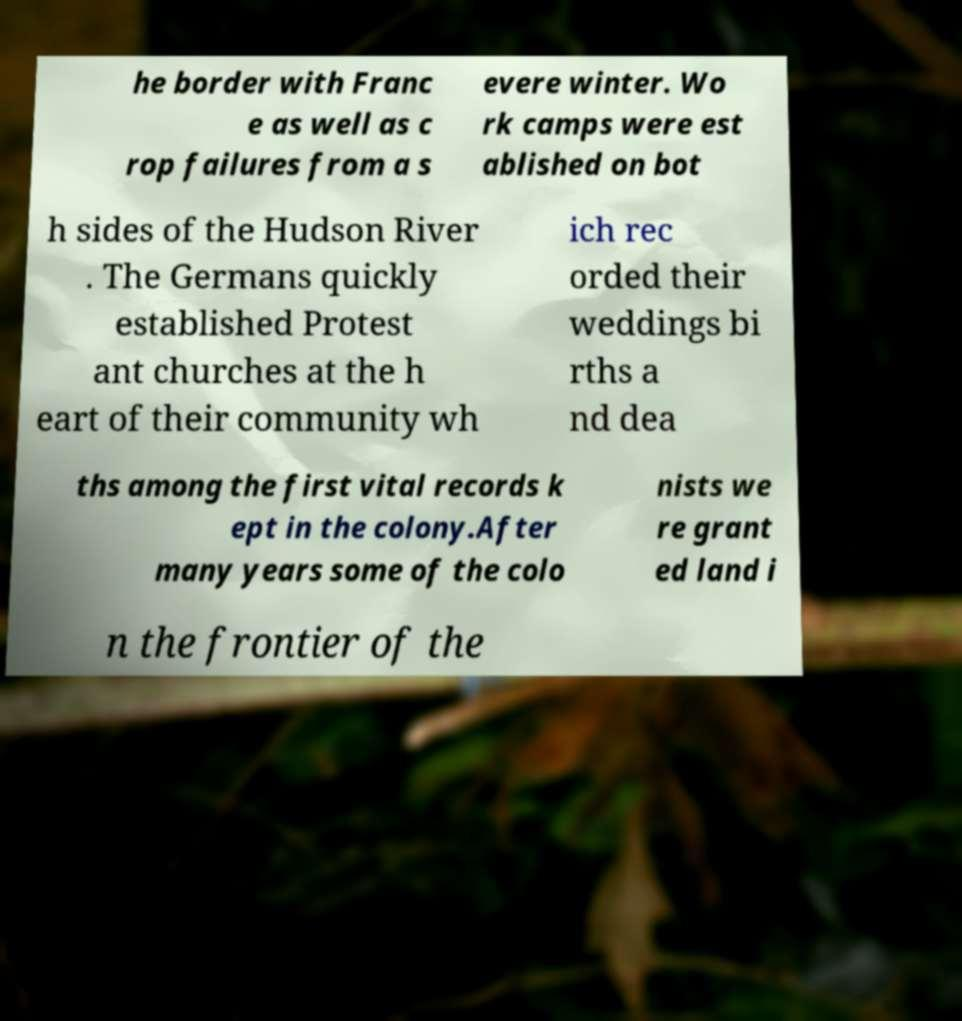Could you extract and type out the text from this image? he border with Franc e as well as c rop failures from a s evere winter. Wo rk camps were est ablished on bot h sides of the Hudson River . The Germans quickly established Protest ant churches at the h eart of their community wh ich rec orded their weddings bi rths a nd dea ths among the first vital records k ept in the colony.After many years some of the colo nists we re grant ed land i n the frontier of the 